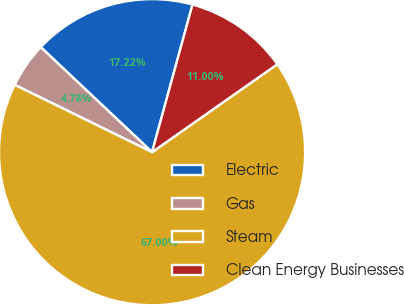<chart> <loc_0><loc_0><loc_500><loc_500><pie_chart><fcel>Electric<fcel>Gas<fcel>Steam<fcel>Clean Energy Businesses<nl><fcel>17.22%<fcel>4.78%<fcel>66.99%<fcel>11.0%<nl></chart> 